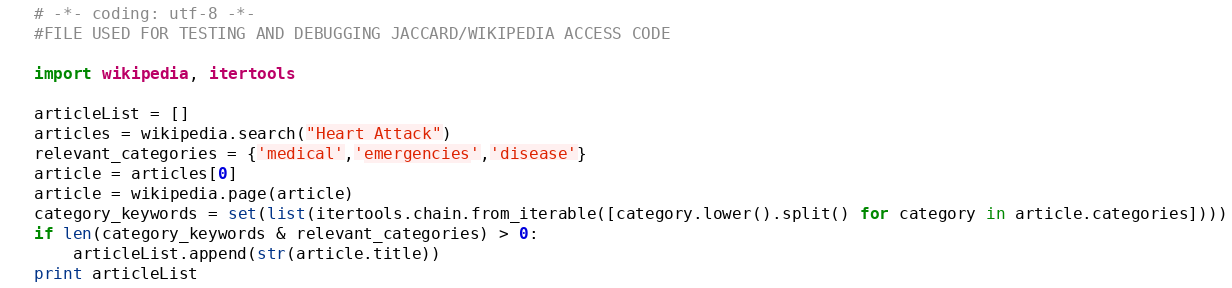<code> <loc_0><loc_0><loc_500><loc_500><_Python_># -*- coding: utf-8 -*-
#FILE USED FOR TESTING AND DEBUGGING JACCARD/WIKIPEDIA ACCESS CODE

import wikipedia, itertools

articleList = []
articles = wikipedia.search("Heart Attack")
relevant_categories = {'medical','emergencies','disease'}
article = articles[0]
article = wikipedia.page(article)
category_keywords = set(list(itertools.chain.from_iterable([category.lower().split() for category in article.categories])))
if len(category_keywords & relevant_categories) > 0:
    articleList.append(str(article.title))
print articleList
</code> 